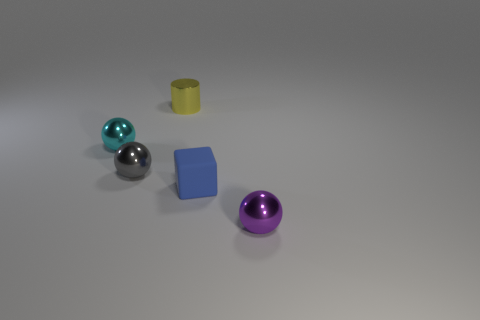There is a cyan sphere that is the same size as the metal cylinder; what is its material?
Keep it short and to the point. Metal. There is a tiny shiny ball that is right of the small cyan shiny sphere and left of the tiny purple object; what is its color?
Ensure brevity in your answer.  Gray. There is a ball to the right of the gray object on the left side of the tiny shiny object behind the cyan metallic sphere; how big is it?
Provide a succinct answer. Small. How many things are either shiny objects behind the cyan metallic ball or tiny things to the left of the tiny purple metal sphere?
Offer a very short reply. 4. What is the shape of the small yellow metal object?
Ensure brevity in your answer.  Cylinder. How many other things are made of the same material as the yellow thing?
Provide a short and direct response. 3. What is the size of the gray thing that is the same shape as the purple metallic object?
Provide a succinct answer. Small. There is a sphere on the right side of the shiny thing that is behind the tiny cyan metal object that is left of the yellow object; what is it made of?
Provide a short and direct response. Metal. Are any purple cubes visible?
Ensure brevity in your answer.  No. What color is the small rubber block?
Ensure brevity in your answer.  Blue. 